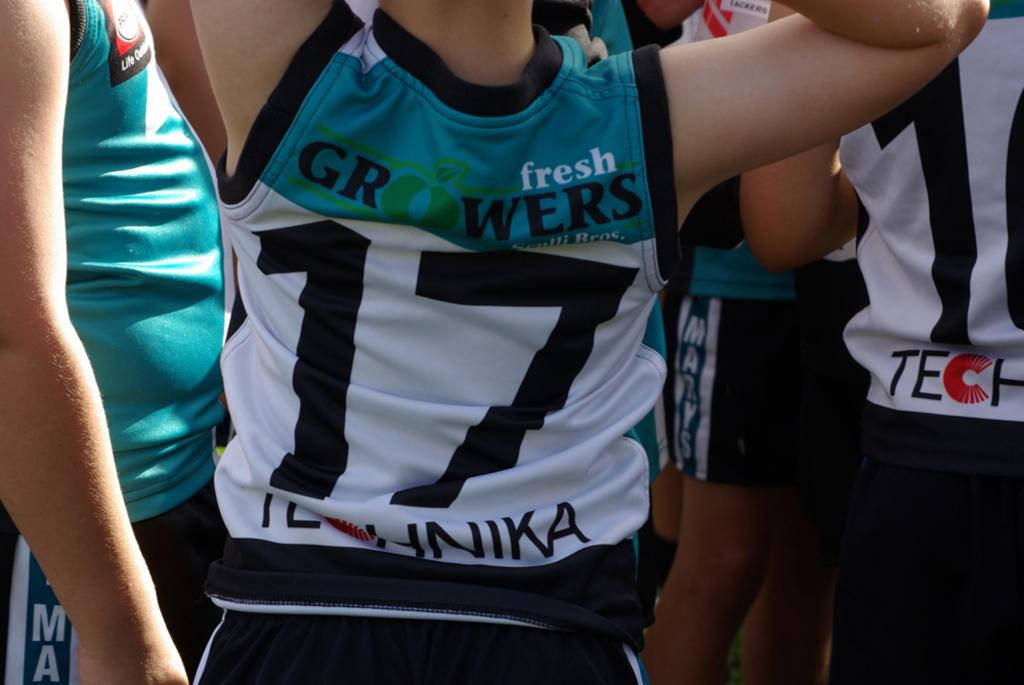<image>
Offer a succinct explanation of the picture presented. The torso of an athlete in a fresh Growers #17 shirt is pictured. 